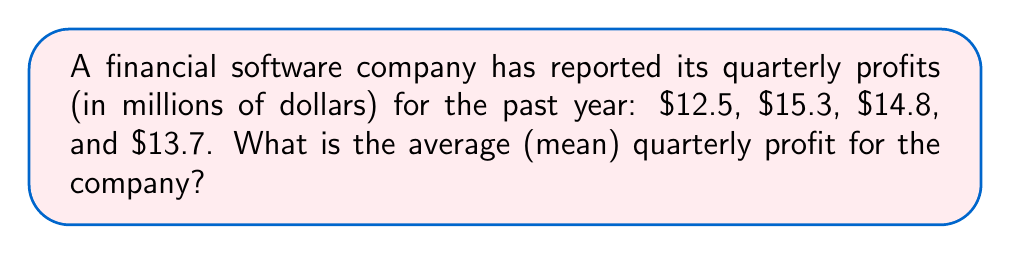What is the answer to this math problem? To find the average (mean) of a set of numbers, we follow these steps:

1. Sum up all the values in the set:
   $$12.5 + 15.3 + 14.8 + 13.7 = 56.3$$

2. Count the total number of values in the set:
   There are 4 quarterly profits.

3. Divide the sum by the total number of values:
   $$\text{Average} = \frac{\text{Sum of values}}{\text{Number of values}} = \frac{56.3}{4} = 14.075$$

Therefore, the average quarterly profit is $14.075 million.
Answer: $14.075 million 